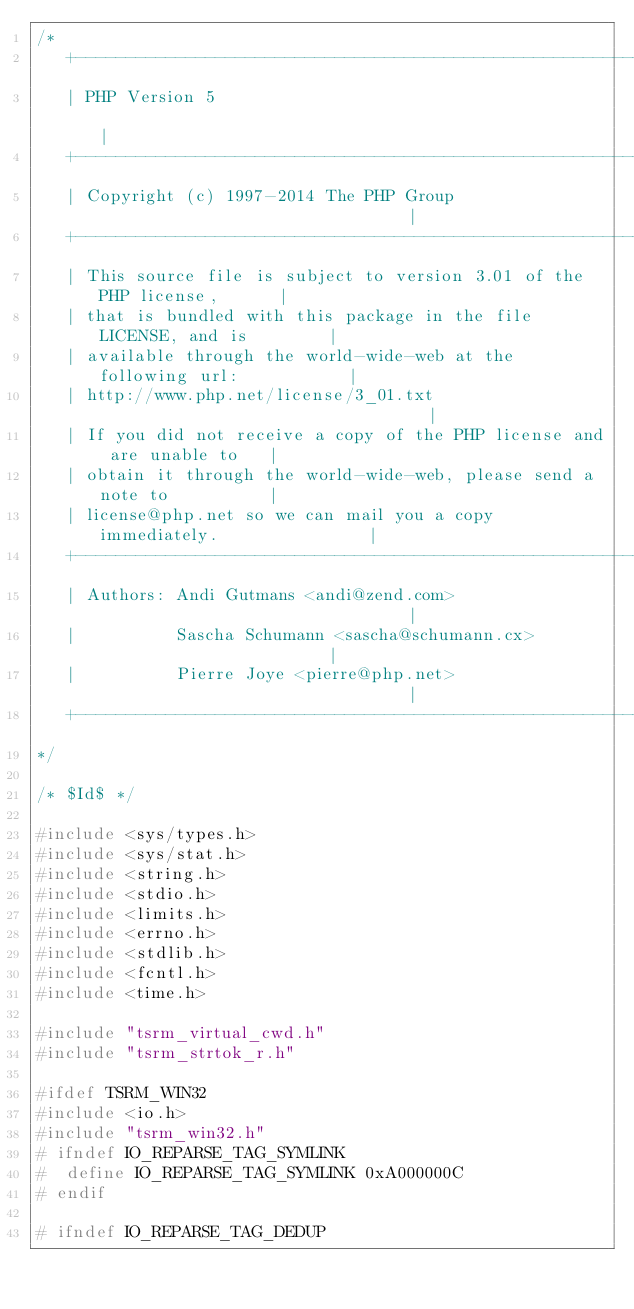<code> <loc_0><loc_0><loc_500><loc_500><_C_>/*
   +----------------------------------------------------------------------+
   | PHP Version 5                                                        |
   +----------------------------------------------------------------------+
   | Copyright (c) 1997-2014 The PHP Group                                |
   +----------------------------------------------------------------------+
   | This source file is subject to version 3.01 of the PHP license,      |
   | that is bundled with this package in the file LICENSE, and is        |
   | available through the world-wide-web at the following url:           |
   | http://www.php.net/license/3_01.txt                                  |
   | If you did not receive a copy of the PHP license and are unable to   |
   | obtain it through the world-wide-web, please send a note to          |
   | license@php.net so we can mail you a copy immediately.               |
   +----------------------------------------------------------------------+
   | Authors: Andi Gutmans <andi@zend.com>                                |
   |          Sascha Schumann <sascha@schumann.cx>                        |
   |          Pierre Joye <pierre@php.net>                                |
   +----------------------------------------------------------------------+
*/

/* $Id$ */

#include <sys/types.h>
#include <sys/stat.h>
#include <string.h>
#include <stdio.h>
#include <limits.h>
#include <errno.h>
#include <stdlib.h>
#include <fcntl.h>
#include <time.h>

#include "tsrm_virtual_cwd.h"
#include "tsrm_strtok_r.h"

#ifdef TSRM_WIN32
#include <io.h>
#include "tsrm_win32.h"
# ifndef IO_REPARSE_TAG_SYMLINK
#  define IO_REPARSE_TAG_SYMLINK 0xA000000C
# endif

# ifndef IO_REPARSE_TAG_DEDUP</code> 